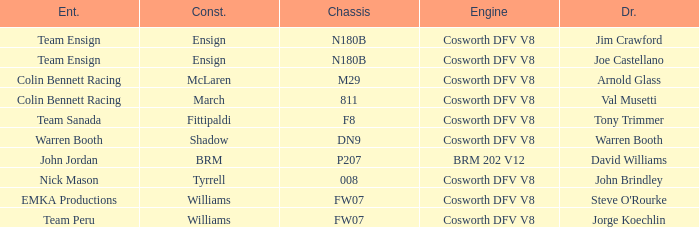What engine is used by Colin Bennett Racing with an 811 chassis? Cosworth DFV V8. 